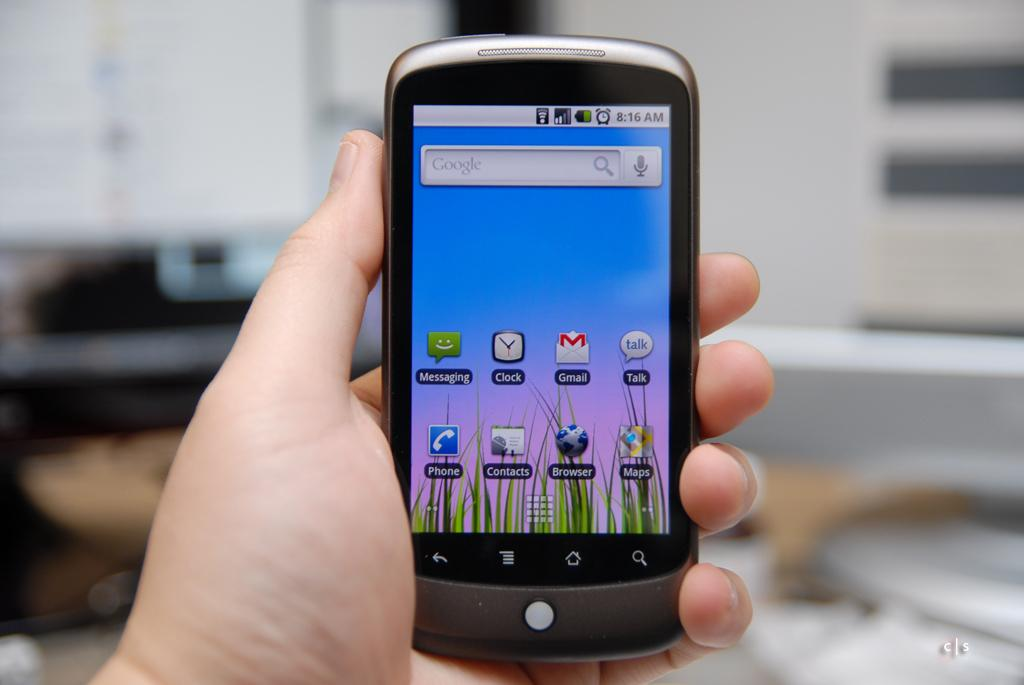<image>
Relay a brief, clear account of the picture shown. a girl has a smart phone with google on the screen 